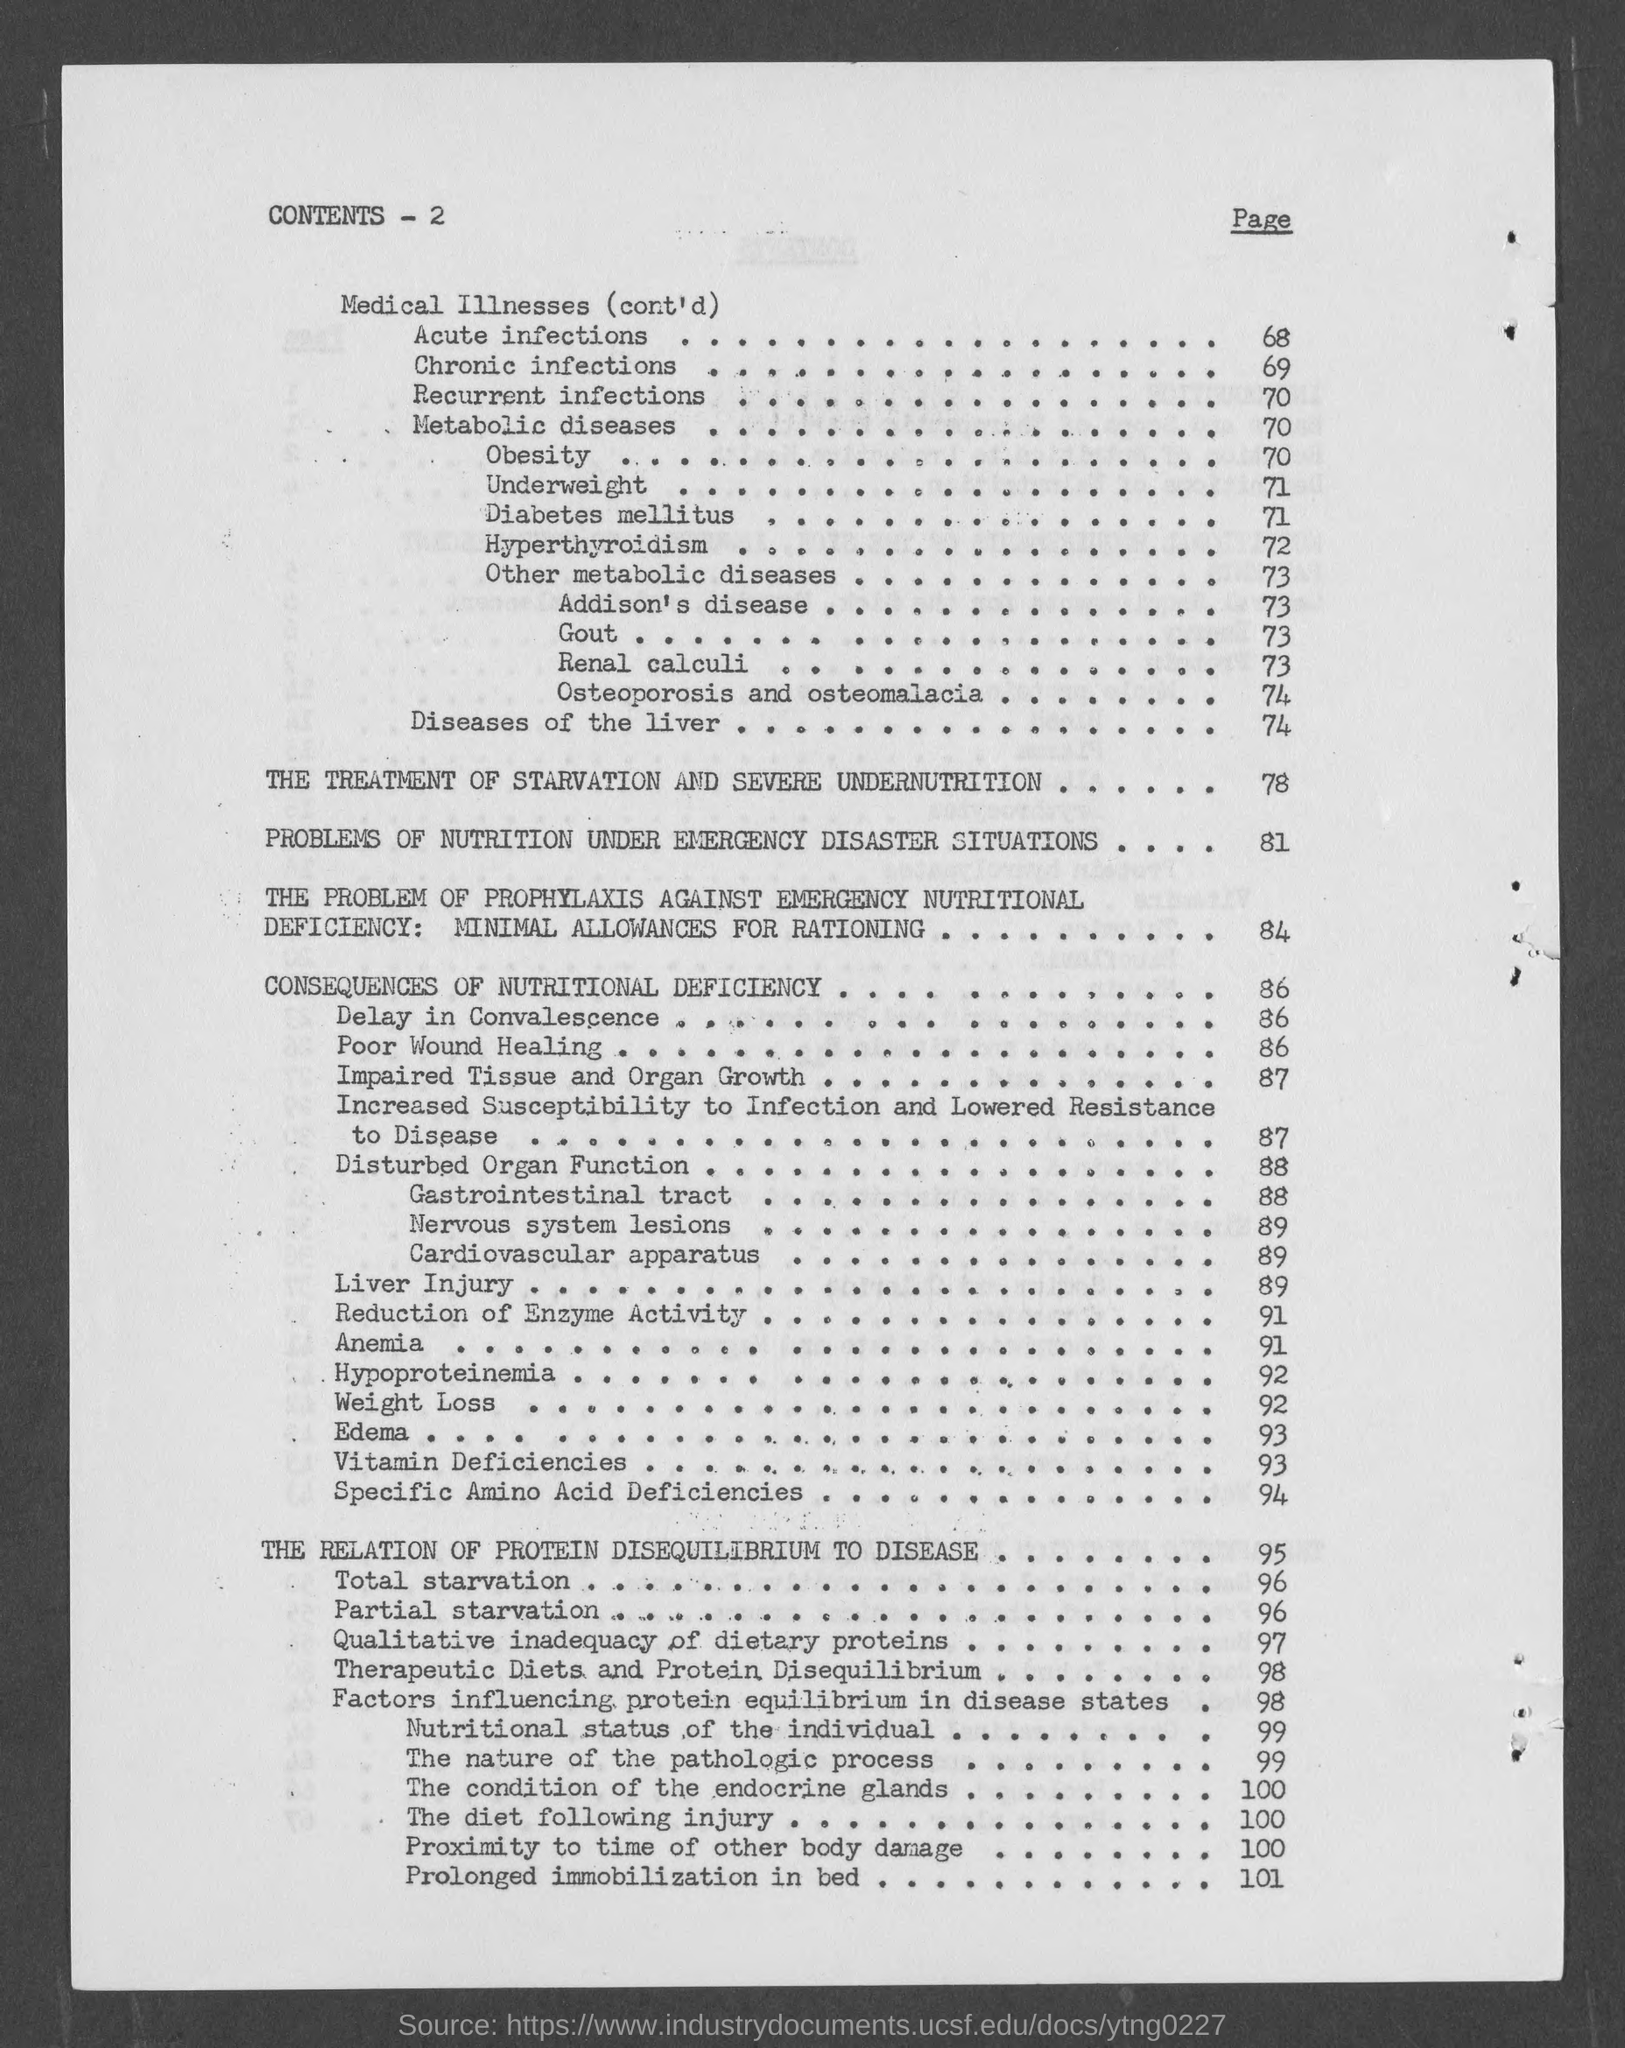Identify some key points in this picture. On page 89, the topic of liver injury can be found. The content at page 95 is about the relationship between protein disequilibrium and disease. On page 70, the term "Recurrent infections" is mentioned. Page 69 contains the entry for "Chronic infections. 